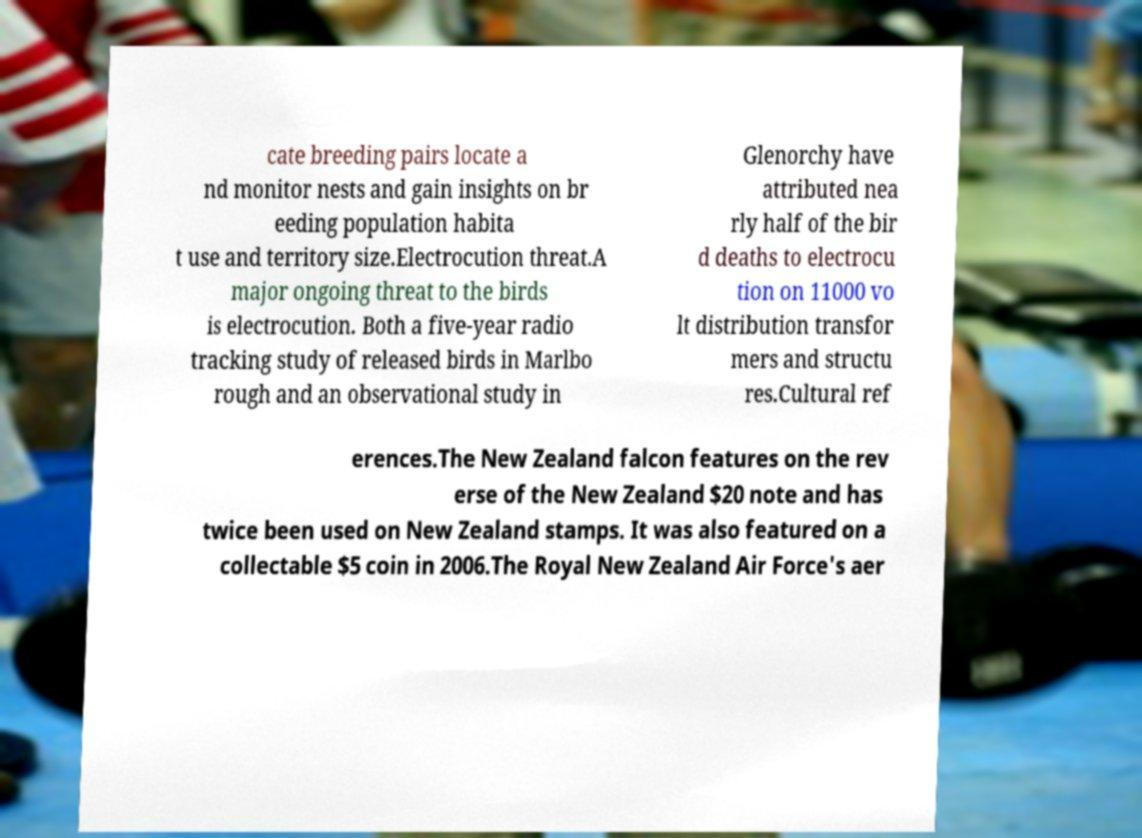Please identify and transcribe the text found in this image. cate breeding pairs locate a nd monitor nests and gain insights on br eeding population habita t use and territory size.Electrocution threat.A major ongoing threat to the birds is electrocution. Both a five-year radio tracking study of released birds in Marlbo rough and an observational study in Glenorchy have attributed nea rly half of the bir d deaths to electrocu tion on 11000 vo lt distribution transfor mers and structu res.Cultural ref erences.The New Zealand falcon features on the rev erse of the New Zealand $20 note and has twice been used on New Zealand stamps. It was also featured on a collectable $5 coin in 2006.The Royal New Zealand Air Force's aer 